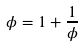Convert formula to latex. <formula><loc_0><loc_0><loc_500><loc_500>\phi = 1 + \frac { 1 } { \phi }</formula> 